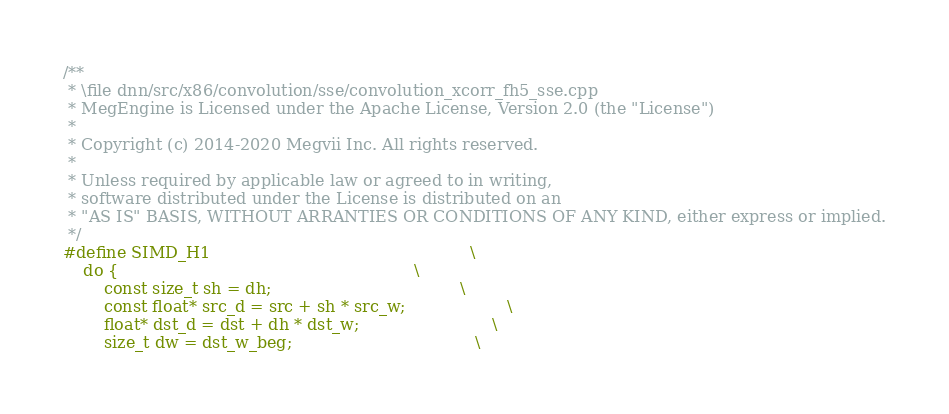<code> <loc_0><loc_0><loc_500><loc_500><_C++_>/**
 * \file dnn/src/x86/convolution/sse/convolution_xcorr_fh5_sse.cpp
 * MegEngine is Licensed under the Apache License, Version 2.0 (the "License")
 *
 * Copyright (c) 2014-2020 Megvii Inc. All rights reserved.
 *
 * Unless required by applicable law or agreed to in writing,
 * software distributed under the License is distributed on an
 * "AS IS" BASIS, WITHOUT ARRANTIES OR CONDITIONS OF ANY KIND, either express or implied.
 */
#define SIMD_H1                                                   \
    do {                                                          \
        const size_t sh = dh;                                     \
        const float* src_d = src + sh * src_w;                    \
        float* dst_d = dst + dh * dst_w;                          \
        size_t dw = dst_w_beg;                                    \</code> 